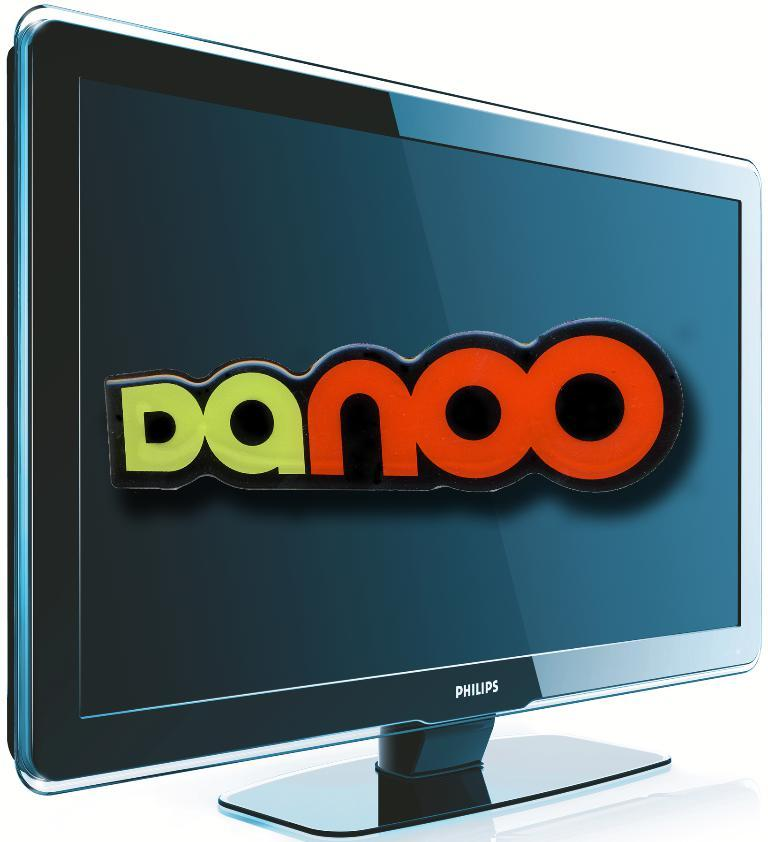<image>
Summarize the visual content of the image. A Philips TV screen shows the word Danoo on its screen. 